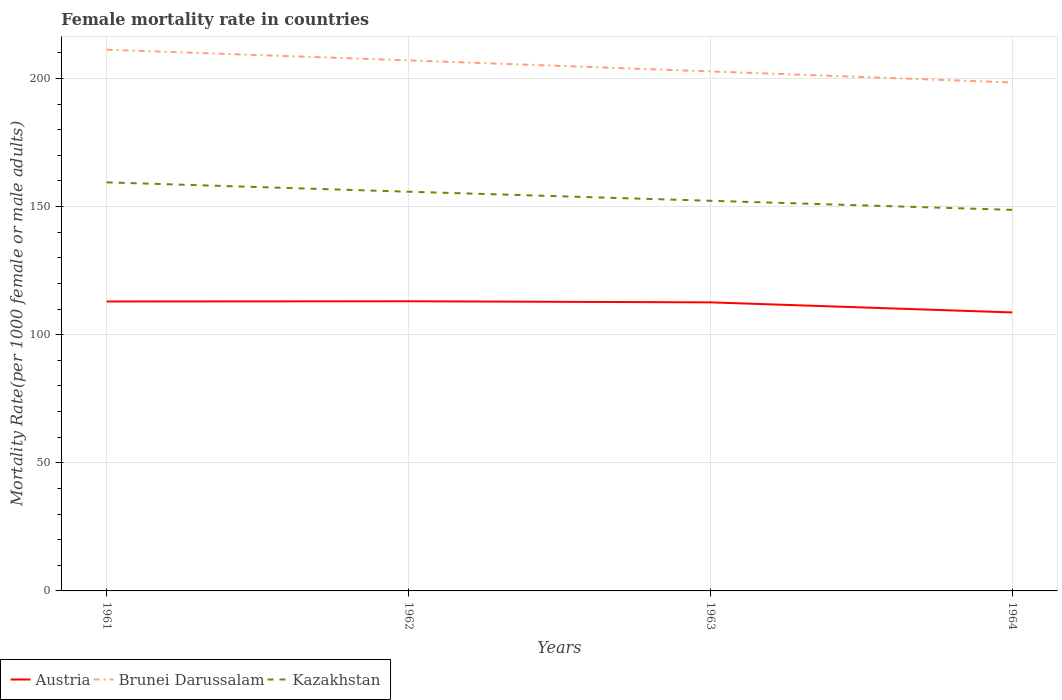How many different coloured lines are there?
Your answer should be compact. 3. Is the number of lines equal to the number of legend labels?
Your answer should be compact. Yes. Across all years, what is the maximum female mortality rate in Kazakhstan?
Provide a succinct answer. 148.73. In which year was the female mortality rate in Kazakhstan maximum?
Your answer should be very brief. 1964. What is the total female mortality rate in Kazakhstan in the graph?
Give a very brief answer. 3.54. What is the difference between the highest and the second highest female mortality rate in Kazakhstan?
Your answer should be very brief. 10.74. How many lines are there?
Give a very brief answer. 3. Does the graph contain any zero values?
Provide a succinct answer. No. Does the graph contain grids?
Offer a terse response. Yes. How are the legend labels stacked?
Your answer should be very brief. Horizontal. What is the title of the graph?
Your answer should be very brief. Female mortality rate in countries. What is the label or title of the X-axis?
Offer a terse response. Years. What is the label or title of the Y-axis?
Ensure brevity in your answer.  Mortality Rate(per 1000 female or male adults). What is the Mortality Rate(per 1000 female or male adults) in Austria in 1961?
Your response must be concise. 112.97. What is the Mortality Rate(per 1000 female or male adults) in Brunei Darussalam in 1961?
Provide a succinct answer. 211.24. What is the Mortality Rate(per 1000 female or male adults) of Kazakhstan in 1961?
Your response must be concise. 159.47. What is the Mortality Rate(per 1000 female or male adults) in Austria in 1962?
Make the answer very short. 113.06. What is the Mortality Rate(per 1000 female or male adults) in Brunei Darussalam in 1962?
Provide a succinct answer. 207.09. What is the Mortality Rate(per 1000 female or male adults) in Kazakhstan in 1962?
Provide a short and direct response. 155.82. What is the Mortality Rate(per 1000 female or male adults) in Austria in 1963?
Your answer should be very brief. 112.63. What is the Mortality Rate(per 1000 female or male adults) in Brunei Darussalam in 1963?
Your answer should be very brief. 202.77. What is the Mortality Rate(per 1000 female or male adults) of Kazakhstan in 1963?
Make the answer very short. 152.28. What is the Mortality Rate(per 1000 female or male adults) of Austria in 1964?
Your response must be concise. 108.69. What is the Mortality Rate(per 1000 female or male adults) in Brunei Darussalam in 1964?
Keep it short and to the point. 198.46. What is the Mortality Rate(per 1000 female or male adults) of Kazakhstan in 1964?
Give a very brief answer. 148.73. Across all years, what is the maximum Mortality Rate(per 1000 female or male adults) in Austria?
Ensure brevity in your answer.  113.06. Across all years, what is the maximum Mortality Rate(per 1000 female or male adults) of Brunei Darussalam?
Keep it short and to the point. 211.24. Across all years, what is the maximum Mortality Rate(per 1000 female or male adults) of Kazakhstan?
Make the answer very short. 159.47. Across all years, what is the minimum Mortality Rate(per 1000 female or male adults) in Austria?
Provide a succinct answer. 108.69. Across all years, what is the minimum Mortality Rate(per 1000 female or male adults) in Brunei Darussalam?
Give a very brief answer. 198.46. Across all years, what is the minimum Mortality Rate(per 1000 female or male adults) of Kazakhstan?
Offer a very short reply. 148.73. What is the total Mortality Rate(per 1000 female or male adults) of Austria in the graph?
Ensure brevity in your answer.  447.35. What is the total Mortality Rate(per 1000 female or male adults) in Brunei Darussalam in the graph?
Give a very brief answer. 819.55. What is the total Mortality Rate(per 1000 female or male adults) of Kazakhstan in the graph?
Ensure brevity in your answer.  616.3. What is the difference between the Mortality Rate(per 1000 female or male adults) of Austria in 1961 and that in 1962?
Your answer should be very brief. -0.09. What is the difference between the Mortality Rate(per 1000 female or male adults) in Brunei Darussalam in 1961 and that in 1962?
Keep it short and to the point. 4.16. What is the difference between the Mortality Rate(per 1000 female or male adults) of Kazakhstan in 1961 and that in 1962?
Make the answer very short. 3.65. What is the difference between the Mortality Rate(per 1000 female or male adults) of Austria in 1961 and that in 1963?
Make the answer very short. 0.34. What is the difference between the Mortality Rate(per 1000 female or male adults) in Brunei Darussalam in 1961 and that in 1963?
Your answer should be compact. 8.47. What is the difference between the Mortality Rate(per 1000 female or male adults) in Kazakhstan in 1961 and that in 1963?
Your answer should be very brief. 7.19. What is the difference between the Mortality Rate(per 1000 female or male adults) of Austria in 1961 and that in 1964?
Offer a very short reply. 4.28. What is the difference between the Mortality Rate(per 1000 female or male adults) of Brunei Darussalam in 1961 and that in 1964?
Your response must be concise. 12.79. What is the difference between the Mortality Rate(per 1000 female or male adults) in Kazakhstan in 1961 and that in 1964?
Provide a short and direct response. 10.74. What is the difference between the Mortality Rate(per 1000 female or male adults) in Austria in 1962 and that in 1963?
Your response must be concise. 0.43. What is the difference between the Mortality Rate(per 1000 female or male adults) in Brunei Darussalam in 1962 and that in 1963?
Offer a terse response. 4.32. What is the difference between the Mortality Rate(per 1000 female or male adults) of Kazakhstan in 1962 and that in 1963?
Provide a short and direct response. 3.54. What is the difference between the Mortality Rate(per 1000 female or male adults) of Austria in 1962 and that in 1964?
Your answer should be very brief. 4.36. What is the difference between the Mortality Rate(per 1000 female or male adults) of Brunei Darussalam in 1962 and that in 1964?
Provide a short and direct response. 8.63. What is the difference between the Mortality Rate(per 1000 female or male adults) of Kazakhstan in 1962 and that in 1964?
Keep it short and to the point. 7.09. What is the difference between the Mortality Rate(per 1000 female or male adults) in Austria in 1963 and that in 1964?
Your answer should be very brief. 3.93. What is the difference between the Mortality Rate(per 1000 female or male adults) of Brunei Darussalam in 1963 and that in 1964?
Offer a very short reply. 4.32. What is the difference between the Mortality Rate(per 1000 female or male adults) in Kazakhstan in 1963 and that in 1964?
Make the answer very short. 3.54. What is the difference between the Mortality Rate(per 1000 female or male adults) of Austria in 1961 and the Mortality Rate(per 1000 female or male adults) of Brunei Darussalam in 1962?
Provide a short and direct response. -94.11. What is the difference between the Mortality Rate(per 1000 female or male adults) in Austria in 1961 and the Mortality Rate(per 1000 female or male adults) in Kazakhstan in 1962?
Your response must be concise. -42.85. What is the difference between the Mortality Rate(per 1000 female or male adults) of Brunei Darussalam in 1961 and the Mortality Rate(per 1000 female or male adults) of Kazakhstan in 1962?
Your answer should be compact. 55.42. What is the difference between the Mortality Rate(per 1000 female or male adults) in Austria in 1961 and the Mortality Rate(per 1000 female or male adults) in Brunei Darussalam in 1963?
Offer a very short reply. -89.8. What is the difference between the Mortality Rate(per 1000 female or male adults) in Austria in 1961 and the Mortality Rate(per 1000 female or male adults) in Kazakhstan in 1963?
Provide a succinct answer. -39.31. What is the difference between the Mortality Rate(per 1000 female or male adults) of Brunei Darussalam in 1961 and the Mortality Rate(per 1000 female or male adults) of Kazakhstan in 1963?
Keep it short and to the point. 58.96. What is the difference between the Mortality Rate(per 1000 female or male adults) in Austria in 1961 and the Mortality Rate(per 1000 female or male adults) in Brunei Darussalam in 1964?
Your answer should be very brief. -85.48. What is the difference between the Mortality Rate(per 1000 female or male adults) in Austria in 1961 and the Mortality Rate(per 1000 female or male adults) in Kazakhstan in 1964?
Provide a succinct answer. -35.76. What is the difference between the Mortality Rate(per 1000 female or male adults) in Brunei Darussalam in 1961 and the Mortality Rate(per 1000 female or male adults) in Kazakhstan in 1964?
Offer a terse response. 62.51. What is the difference between the Mortality Rate(per 1000 female or male adults) in Austria in 1962 and the Mortality Rate(per 1000 female or male adults) in Brunei Darussalam in 1963?
Give a very brief answer. -89.71. What is the difference between the Mortality Rate(per 1000 female or male adults) of Austria in 1962 and the Mortality Rate(per 1000 female or male adults) of Kazakhstan in 1963?
Keep it short and to the point. -39.22. What is the difference between the Mortality Rate(per 1000 female or male adults) of Brunei Darussalam in 1962 and the Mortality Rate(per 1000 female or male adults) of Kazakhstan in 1963?
Provide a succinct answer. 54.81. What is the difference between the Mortality Rate(per 1000 female or male adults) in Austria in 1962 and the Mortality Rate(per 1000 female or male adults) in Brunei Darussalam in 1964?
Your response must be concise. -85.4. What is the difference between the Mortality Rate(per 1000 female or male adults) of Austria in 1962 and the Mortality Rate(per 1000 female or male adults) of Kazakhstan in 1964?
Provide a short and direct response. -35.68. What is the difference between the Mortality Rate(per 1000 female or male adults) of Brunei Darussalam in 1962 and the Mortality Rate(per 1000 female or male adults) of Kazakhstan in 1964?
Make the answer very short. 58.35. What is the difference between the Mortality Rate(per 1000 female or male adults) of Austria in 1963 and the Mortality Rate(per 1000 female or male adults) of Brunei Darussalam in 1964?
Offer a terse response. -85.83. What is the difference between the Mortality Rate(per 1000 female or male adults) of Austria in 1963 and the Mortality Rate(per 1000 female or male adults) of Kazakhstan in 1964?
Make the answer very short. -36.11. What is the difference between the Mortality Rate(per 1000 female or male adults) of Brunei Darussalam in 1963 and the Mortality Rate(per 1000 female or male adults) of Kazakhstan in 1964?
Offer a terse response. 54.04. What is the average Mortality Rate(per 1000 female or male adults) in Austria per year?
Give a very brief answer. 111.84. What is the average Mortality Rate(per 1000 female or male adults) of Brunei Darussalam per year?
Your response must be concise. 204.89. What is the average Mortality Rate(per 1000 female or male adults) in Kazakhstan per year?
Offer a terse response. 154.08. In the year 1961, what is the difference between the Mortality Rate(per 1000 female or male adults) of Austria and Mortality Rate(per 1000 female or male adults) of Brunei Darussalam?
Offer a very short reply. -98.27. In the year 1961, what is the difference between the Mortality Rate(per 1000 female or male adults) in Austria and Mortality Rate(per 1000 female or male adults) in Kazakhstan?
Offer a very short reply. -46.5. In the year 1961, what is the difference between the Mortality Rate(per 1000 female or male adults) of Brunei Darussalam and Mortality Rate(per 1000 female or male adults) of Kazakhstan?
Your answer should be compact. 51.77. In the year 1962, what is the difference between the Mortality Rate(per 1000 female or male adults) of Austria and Mortality Rate(per 1000 female or male adults) of Brunei Darussalam?
Give a very brief answer. -94.03. In the year 1962, what is the difference between the Mortality Rate(per 1000 female or male adults) in Austria and Mortality Rate(per 1000 female or male adults) in Kazakhstan?
Your answer should be compact. -42.76. In the year 1962, what is the difference between the Mortality Rate(per 1000 female or male adults) in Brunei Darussalam and Mortality Rate(per 1000 female or male adults) in Kazakhstan?
Keep it short and to the point. 51.26. In the year 1963, what is the difference between the Mortality Rate(per 1000 female or male adults) of Austria and Mortality Rate(per 1000 female or male adults) of Brunei Darussalam?
Make the answer very short. -90.14. In the year 1963, what is the difference between the Mortality Rate(per 1000 female or male adults) in Austria and Mortality Rate(per 1000 female or male adults) in Kazakhstan?
Keep it short and to the point. -39.65. In the year 1963, what is the difference between the Mortality Rate(per 1000 female or male adults) in Brunei Darussalam and Mortality Rate(per 1000 female or male adults) in Kazakhstan?
Give a very brief answer. 50.49. In the year 1964, what is the difference between the Mortality Rate(per 1000 female or male adults) of Austria and Mortality Rate(per 1000 female or male adults) of Brunei Darussalam?
Make the answer very short. -89.76. In the year 1964, what is the difference between the Mortality Rate(per 1000 female or male adults) in Austria and Mortality Rate(per 1000 female or male adults) in Kazakhstan?
Provide a succinct answer. -40.04. In the year 1964, what is the difference between the Mortality Rate(per 1000 female or male adults) in Brunei Darussalam and Mortality Rate(per 1000 female or male adults) in Kazakhstan?
Make the answer very short. 49.72. What is the ratio of the Mortality Rate(per 1000 female or male adults) of Austria in 1961 to that in 1962?
Make the answer very short. 1. What is the ratio of the Mortality Rate(per 1000 female or male adults) of Brunei Darussalam in 1961 to that in 1962?
Your answer should be compact. 1.02. What is the ratio of the Mortality Rate(per 1000 female or male adults) in Kazakhstan in 1961 to that in 1962?
Offer a terse response. 1.02. What is the ratio of the Mortality Rate(per 1000 female or male adults) of Brunei Darussalam in 1961 to that in 1963?
Give a very brief answer. 1.04. What is the ratio of the Mortality Rate(per 1000 female or male adults) of Kazakhstan in 1961 to that in 1963?
Keep it short and to the point. 1.05. What is the ratio of the Mortality Rate(per 1000 female or male adults) in Austria in 1961 to that in 1964?
Ensure brevity in your answer.  1.04. What is the ratio of the Mortality Rate(per 1000 female or male adults) in Brunei Darussalam in 1961 to that in 1964?
Give a very brief answer. 1.06. What is the ratio of the Mortality Rate(per 1000 female or male adults) in Kazakhstan in 1961 to that in 1964?
Make the answer very short. 1.07. What is the ratio of the Mortality Rate(per 1000 female or male adults) in Austria in 1962 to that in 1963?
Make the answer very short. 1. What is the ratio of the Mortality Rate(per 1000 female or male adults) of Brunei Darussalam in 1962 to that in 1963?
Your answer should be very brief. 1.02. What is the ratio of the Mortality Rate(per 1000 female or male adults) of Kazakhstan in 1962 to that in 1963?
Offer a very short reply. 1.02. What is the ratio of the Mortality Rate(per 1000 female or male adults) in Austria in 1962 to that in 1964?
Your answer should be very brief. 1.04. What is the ratio of the Mortality Rate(per 1000 female or male adults) in Brunei Darussalam in 1962 to that in 1964?
Make the answer very short. 1.04. What is the ratio of the Mortality Rate(per 1000 female or male adults) of Kazakhstan in 1962 to that in 1964?
Your answer should be compact. 1.05. What is the ratio of the Mortality Rate(per 1000 female or male adults) in Austria in 1963 to that in 1964?
Your answer should be compact. 1.04. What is the ratio of the Mortality Rate(per 1000 female or male adults) in Brunei Darussalam in 1963 to that in 1964?
Ensure brevity in your answer.  1.02. What is the ratio of the Mortality Rate(per 1000 female or male adults) in Kazakhstan in 1963 to that in 1964?
Offer a terse response. 1.02. What is the difference between the highest and the second highest Mortality Rate(per 1000 female or male adults) in Austria?
Give a very brief answer. 0.09. What is the difference between the highest and the second highest Mortality Rate(per 1000 female or male adults) in Brunei Darussalam?
Your answer should be very brief. 4.16. What is the difference between the highest and the second highest Mortality Rate(per 1000 female or male adults) in Kazakhstan?
Provide a short and direct response. 3.65. What is the difference between the highest and the lowest Mortality Rate(per 1000 female or male adults) of Austria?
Make the answer very short. 4.36. What is the difference between the highest and the lowest Mortality Rate(per 1000 female or male adults) of Brunei Darussalam?
Your answer should be compact. 12.79. What is the difference between the highest and the lowest Mortality Rate(per 1000 female or male adults) in Kazakhstan?
Offer a very short reply. 10.74. 